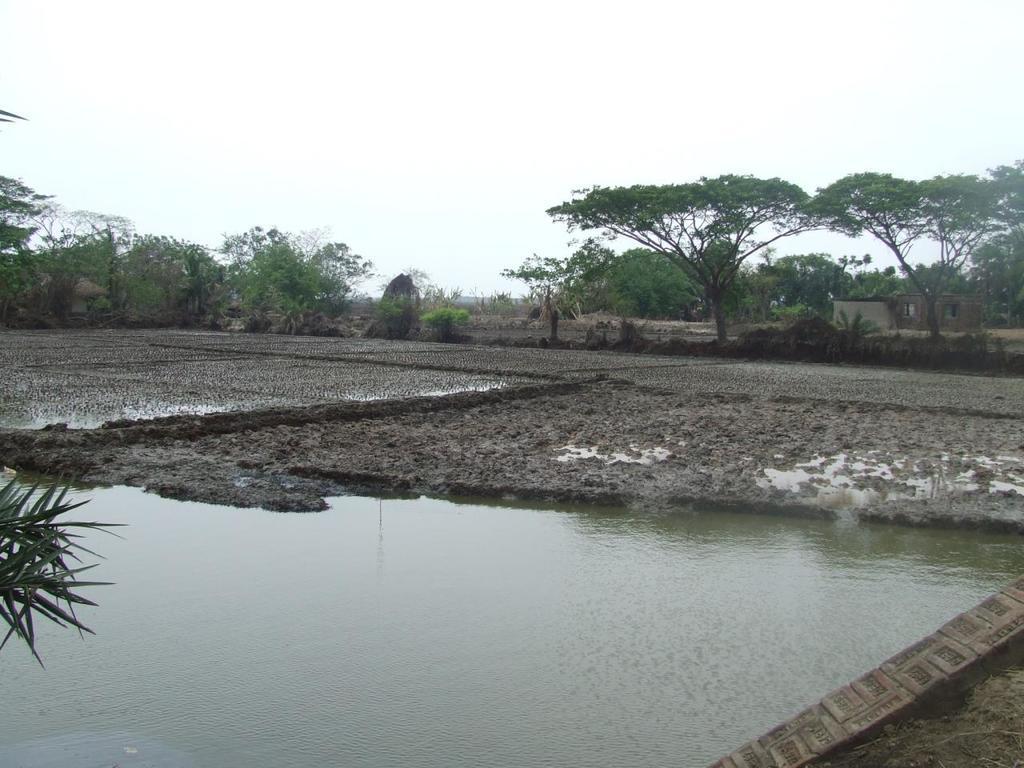In one or two sentences, can you explain what this image depicts? This image consists of water at the bottom. There are trees in the middle. There is sky at the top. There is mud in the middle. 